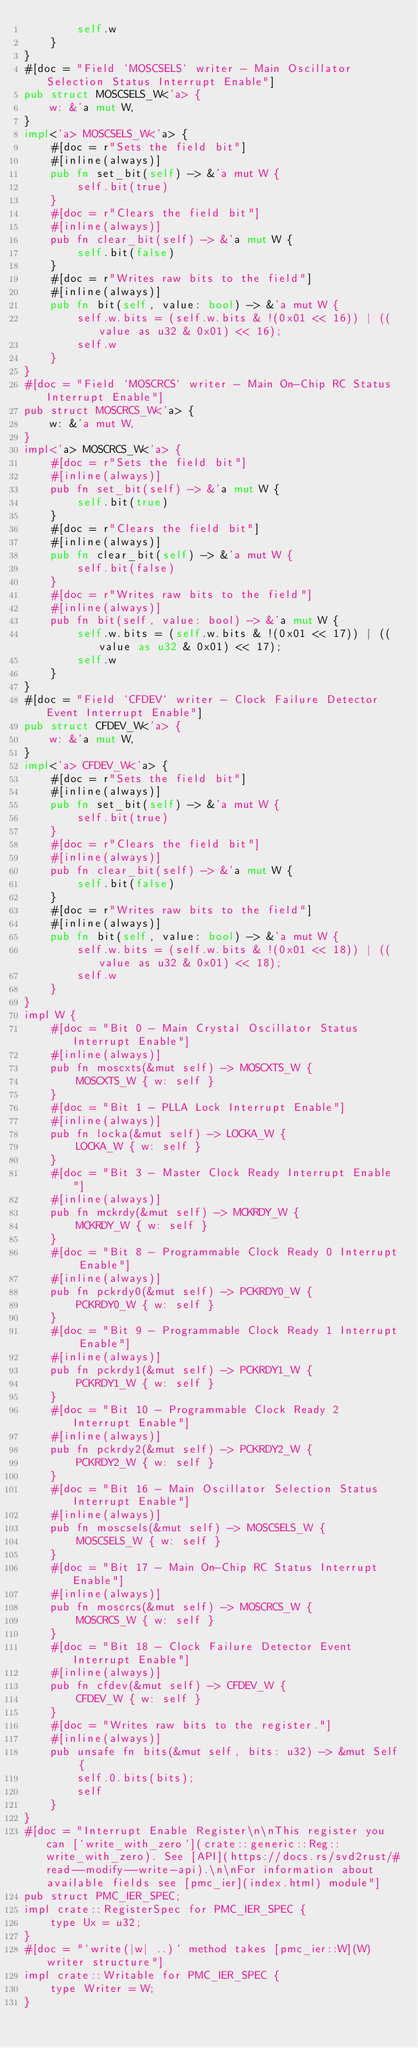<code> <loc_0><loc_0><loc_500><loc_500><_Rust_>        self.w
    }
}
#[doc = "Field `MOSCSELS` writer - Main Oscillator Selection Status Interrupt Enable"]
pub struct MOSCSELS_W<'a> {
    w: &'a mut W,
}
impl<'a> MOSCSELS_W<'a> {
    #[doc = r"Sets the field bit"]
    #[inline(always)]
    pub fn set_bit(self) -> &'a mut W {
        self.bit(true)
    }
    #[doc = r"Clears the field bit"]
    #[inline(always)]
    pub fn clear_bit(self) -> &'a mut W {
        self.bit(false)
    }
    #[doc = r"Writes raw bits to the field"]
    #[inline(always)]
    pub fn bit(self, value: bool) -> &'a mut W {
        self.w.bits = (self.w.bits & !(0x01 << 16)) | ((value as u32 & 0x01) << 16);
        self.w
    }
}
#[doc = "Field `MOSCRCS` writer - Main On-Chip RC Status Interrupt Enable"]
pub struct MOSCRCS_W<'a> {
    w: &'a mut W,
}
impl<'a> MOSCRCS_W<'a> {
    #[doc = r"Sets the field bit"]
    #[inline(always)]
    pub fn set_bit(self) -> &'a mut W {
        self.bit(true)
    }
    #[doc = r"Clears the field bit"]
    #[inline(always)]
    pub fn clear_bit(self) -> &'a mut W {
        self.bit(false)
    }
    #[doc = r"Writes raw bits to the field"]
    #[inline(always)]
    pub fn bit(self, value: bool) -> &'a mut W {
        self.w.bits = (self.w.bits & !(0x01 << 17)) | ((value as u32 & 0x01) << 17);
        self.w
    }
}
#[doc = "Field `CFDEV` writer - Clock Failure Detector Event Interrupt Enable"]
pub struct CFDEV_W<'a> {
    w: &'a mut W,
}
impl<'a> CFDEV_W<'a> {
    #[doc = r"Sets the field bit"]
    #[inline(always)]
    pub fn set_bit(self) -> &'a mut W {
        self.bit(true)
    }
    #[doc = r"Clears the field bit"]
    #[inline(always)]
    pub fn clear_bit(self) -> &'a mut W {
        self.bit(false)
    }
    #[doc = r"Writes raw bits to the field"]
    #[inline(always)]
    pub fn bit(self, value: bool) -> &'a mut W {
        self.w.bits = (self.w.bits & !(0x01 << 18)) | ((value as u32 & 0x01) << 18);
        self.w
    }
}
impl W {
    #[doc = "Bit 0 - Main Crystal Oscillator Status Interrupt Enable"]
    #[inline(always)]
    pub fn moscxts(&mut self) -> MOSCXTS_W {
        MOSCXTS_W { w: self }
    }
    #[doc = "Bit 1 - PLLA Lock Interrupt Enable"]
    #[inline(always)]
    pub fn locka(&mut self) -> LOCKA_W {
        LOCKA_W { w: self }
    }
    #[doc = "Bit 3 - Master Clock Ready Interrupt Enable"]
    #[inline(always)]
    pub fn mckrdy(&mut self) -> MCKRDY_W {
        MCKRDY_W { w: self }
    }
    #[doc = "Bit 8 - Programmable Clock Ready 0 Interrupt Enable"]
    #[inline(always)]
    pub fn pckrdy0(&mut self) -> PCKRDY0_W {
        PCKRDY0_W { w: self }
    }
    #[doc = "Bit 9 - Programmable Clock Ready 1 Interrupt Enable"]
    #[inline(always)]
    pub fn pckrdy1(&mut self) -> PCKRDY1_W {
        PCKRDY1_W { w: self }
    }
    #[doc = "Bit 10 - Programmable Clock Ready 2 Interrupt Enable"]
    #[inline(always)]
    pub fn pckrdy2(&mut self) -> PCKRDY2_W {
        PCKRDY2_W { w: self }
    }
    #[doc = "Bit 16 - Main Oscillator Selection Status Interrupt Enable"]
    #[inline(always)]
    pub fn moscsels(&mut self) -> MOSCSELS_W {
        MOSCSELS_W { w: self }
    }
    #[doc = "Bit 17 - Main On-Chip RC Status Interrupt Enable"]
    #[inline(always)]
    pub fn moscrcs(&mut self) -> MOSCRCS_W {
        MOSCRCS_W { w: self }
    }
    #[doc = "Bit 18 - Clock Failure Detector Event Interrupt Enable"]
    #[inline(always)]
    pub fn cfdev(&mut self) -> CFDEV_W {
        CFDEV_W { w: self }
    }
    #[doc = "Writes raw bits to the register."]
    #[inline(always)]
    pub unsafe fn bits(&mut self, bits: u32) -> &mut Self {
        self.0.bits(bits);
        self
    }
}
#[doc = "Interrupt Enable Register\n\nThis register you can [`write_with_zero`](crate::generic::Reg::write_with_zero). See [API](https://docs.rs/svd2rust/#read--modify--write-api).\n\nFor information about available fields see [pmc_ier](index.html) module"]
pub struct PMC_IER_SPEC;
impl crate::RegisterSpec for PMC_IER_SPEC {
    type Ux = u32;
}
#[doc = "`write(|w| ..)` method takes [pmc_ier::W](W) writer structure"]
impl crate::Writable for PMC_IER_SPEC {
    type Writer = W;
}
</code> 